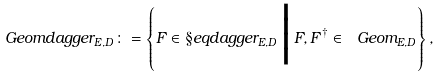<formula> <loc_0><loc_0><loc_500><loc_500>\ G e o m d a g g e r _ { E , D } \colon = \left \{ F \in \S e q d a g g e r _ { E , D } \, \Big | \, F , F ^ { \dagger } \in \ G e o m _ { E , D } \right \} ,</formula> 